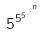<formula> <loc_0><loc_0><loc_500><loc_500>5 ^ { 5 ^ { 5 ^ { . ^ { . ^ { n } } } } }</formula> 